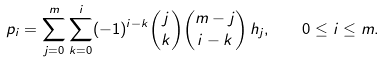Convert formula to latex. <formula><loc_0><loc_0><loc_500><loc_500>p _ { i } = \sum _ { j = 0 } ^ { m } \sum _ { k = 0 } ^ { i } ( - 1 ) ^ { i - k } \binom { j } { k } \binom { m - j } { i - k } \, h _ { j } , \quad 0 \leq i \leq m .</formula> 